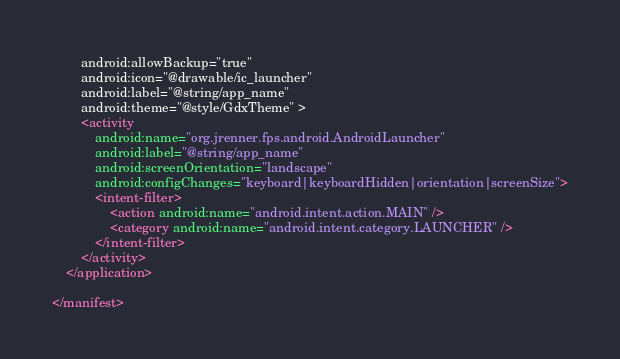Convert code to text. <code><loc_0><loc_0><loc_500><loc_500><_XML_>        android:allowBackup="true"
        android:icon="@drawable/ic_launcher"
        android:label="@string/app_name"
        android:theme="@style/GdxTheme" >
        <activity
            android:name="org.jrenner.fps.android.AndroidLauncher"
            android:label="@string/app_name" 
            android:screenOrientation="landscape"
            android:configChanges="keyboard|keyboardHidden|orientation|screenSize">
            <intent-filter>
                <action android:name="android.intent.action.MAIN" />
                <category android:name="android.intent.category.LAUNCHER" />
            </intent-filter>
        </activity>
    </application>

</manifest>
</code> 